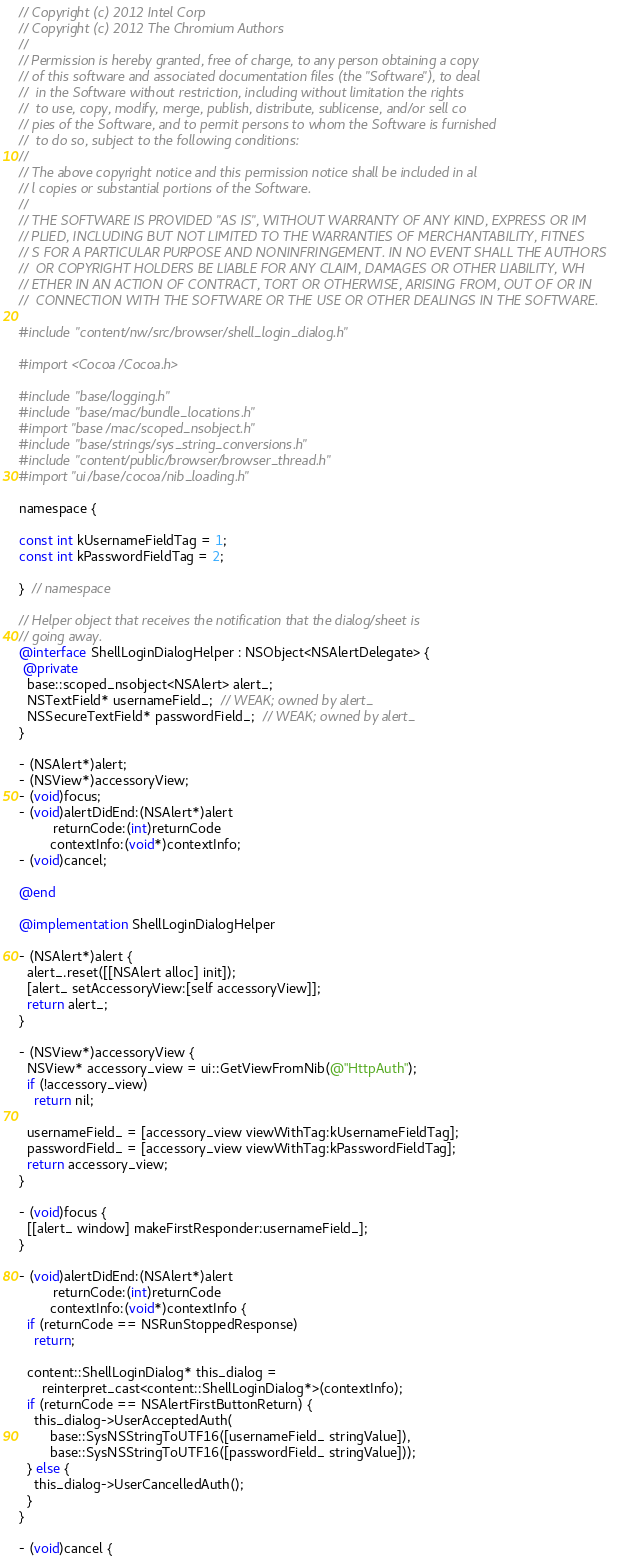Convert code to text. <code><loc_0><loc_0><loc_500><loc_500><_ObjectiveC_>// Copyright (c) 2012 Intel Corp
// Copyright (c) 2012 The Chromium Authors
// 
// Permission is hereby granted, free of charge, to any person obtaining a copy 
// of this software and associated documentation files (the "Software"), to deal
//  in the Software without restriction, including without limitation the rights
//  to use, copy, modify, merge, publish, distribute, sublicense, and/or sell co
// pies of the Software, and to permit persons to whom the Software is furnished
//  to do so, subject to the following conditions:
// 
// The above copyright notice and this permission notice shall be included in al
// l copies or substantial portions of the Software.
// 
// THE SOFTWARE IS PROVIDED "AS IS", WITHOUT WARRANTY OF ANY KIND, EXPRESS OR IM
// PLIED, INCLUDING BUT NOT LIMITED TO THE WARRANTIES OF MERCHANTABILITY, FITNES
// S FOR A PARTICULAR PURPOSE AND NONINFRINGEMENT. IN NO EVENT SHALL THE AUTHORS
//  OR COPYRIGHT HOLDERS BE LIABLE FOR ANY CLAIM, DAMAGES OR OTHER LIABILITY, WH
// ETHER IN AN ACTION OF CONTRACT, TORT OR OTHERWISE, ARISING FROM, OUT OF OR IN
//  CONNECTION WITH THE SOFTWARE OR THE USE OR OTHER DEALINGS IN THE SOFTWARE.

#include "content/nw/src/browser/shell_login_dialog.h"

#import <Cocoa/Cocoa.h>

#include "base/logging.h"
#include "base/mac/bundle_locations.h"
#import "base/mac/scoped_nsobject.h"
#include "base/strings/sys_string_conversions.h"
#include "content/public/browser/browser_thread.h"
#import "ui/base/cocoa/nib_loading.h"

namespace {

const int kUsernameFieldTag = 1;
const int kPasswordFieldTag = 2;

}  // namespace

// Helper object that receives the notification that the dialog/sheet is
// going away.
@interface ShellLoginDialogHelper : NSObject<NSAlertDelegate> {
 @private
  base::scoped_nsobject<NSAlert> alert_;
  NSTextField* usernameField_;  // WEAK; owned by alert_
  NSSecureTextField* passwordField_;  // WEAK; owned by alert_
}

- (NSAlert*)alert;
- (NSView*)accessoryView;
- (void)focus;
- (void)alertDidEnd:(NSAlert*)alert
         returnCode:(int)returnCode
        contextInfo:(void*)contextInfo;
- (void)cancel;

@end

@implementation ShellLoginDialogHelper

- (NSAlert*)alert {
  alert_.reset([[NSAlert alloc] init]);
  [alert_ setAccessoryView:[self accessoryView]];
  return alert_;
}

- (NSView*)accessoryView {
  NSView* accessory_view = ui::GetViewFromNib(@"HttpAuth");
  if (!accessory_view)
    return nil;

  usernameField_ = [accessory_view viewWithTag:kUsernameFieldTag];
  passwordField_ = [accessory_view viewWithTag:kPasswordFieldTag];
  return accessory_view;
}

- (void)focus {
  [[alert_ window] makeFirstResponder:usernameField_];
}

- (void)alertDidEnd:(NSAlert*)alert
         returnCode:(int)returnCode
        contextInfo:(void*)contextInfo {
  if (returnCode == NSRunStoppedResponse)
    return;

  content::ShellLoginDialog* this_dialog =
      reinterpret_cast<content::ShellLoginDialog*>(contextInfo);
  if (returnCode == NSAlertFirstButtonReturn) {
    this_dialog->UserAcceptedAuth(
        base::SysNSStringToUTF16([usernameField_ stringValue]),
        base::SysNSStringToUTF16([passwordField_ stringValue]));
  } else {
    this_dialog->UserCancelledAuth();
  }
}

- (void)cancel {</code> 